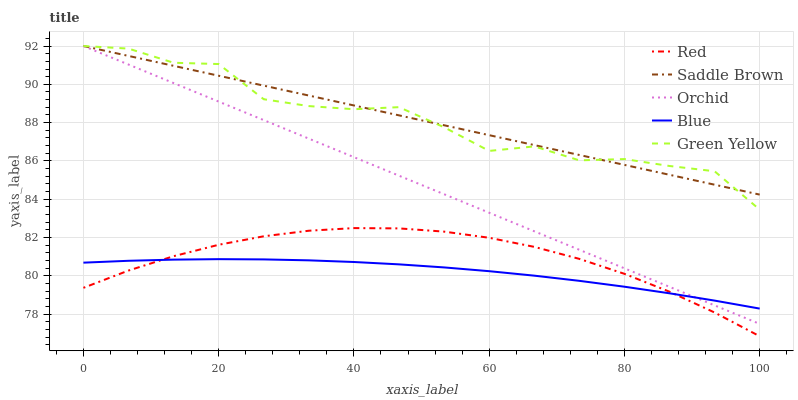Does Blue have the minimum area under the curve?
Answer yes or no. Yes. Does Saddle Brown have the maximum area under the curve?
Answer yes or no. Yes. Does Green Yellow have the minimum area under the curve?
Answer yes or no. No. Does Green Yellow have the maximum area under the curve?
Answer yes or no. No. Is Saddle Brown the smoothest?
Answer yes or no. Yes. Is Green Yellow the roughest?
Answer yes or no. Yes. Is Green Yellow the smoothest?
Answer yes or no. No. Is Saddle Brown the roughest?
Answer yes or no. No. Does Red have the lowest value?
Answer yes or no. Yes. Does Green Yellow have the lowest value?
Answer yes or no. No. Does Orchid have the highest value?
Answer yes or no. Yes. Does Red have the highest value?
Answer yes or no. No. Is Red less than Saddle Brown?
Answer yes or no. Yes. Is Green Yellow greater than Red?
Answer yes or no. Yes. Does Blue intersect Orchid?
Answer yes or no. Yes. Is Blue less than Orchid?
Answer yes or no. No. Is Blue greater than Orchid?
Answer yes or no. No. Does Red intersect Saddle Brown?
Answer yes or no. No. 